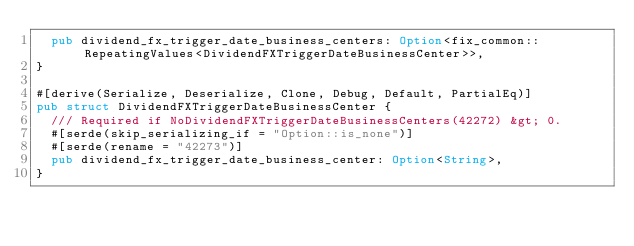Convert code to text. <code><loc_0><loc_0><loc_500><loc_500><_Rust_>	pub dividend_fx_trigger_date_business_centers: Option<fix_common::RepeatingValues<DividendFXTriggerDateBusinessCenter>>,
}

#[derive(Serialize, Deserialize, Clone, Debug, Default, PartialEq)]
pub struct DividendFXTriggerDateBusinessCenter {
	/// Required if NoDividendFXTriggerDateBusinessCenters(42272) &gt; 0.
	#[serde(skip_serializing_if = "Option::is_none")]
	#[serde(rename = "42273")]
	pub dividend_fx_trigger_date_business_center: Option<String>,
}
</code> 